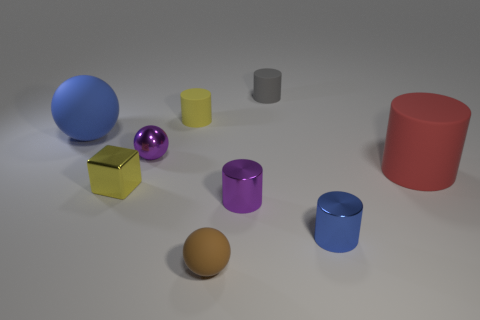Subtract all big matte spheres. How many spheres are left? 2 Subtract all red cylinders. How many cylinders are left? 4 Subtract all cylinders. How many objects are left? 4 Add 1 brown matte balls. How many objects exist? 10 Subtract 0 gray spheres. How many objects are left? 9 Subtract all green spheres. Subtract all purple blocks. How many spheres are left? 3 Subtract all tiny yellow rubber balls. Subtract all large rubber things. How many objects are left? 7 Add 4 small purple objects. How many small purple objects are left? 6 Add 9 green cubes. How many green cubes exist? 9 